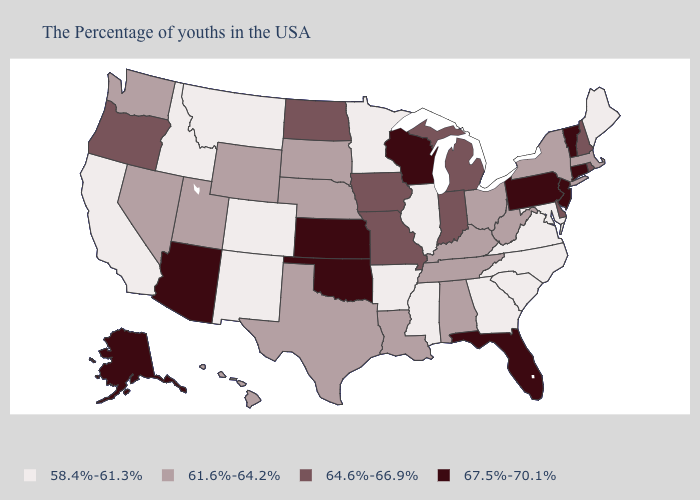Which states have the lowest value in the South?
Write a very short answer. Maryland, Virginia, North Carolina, South Carolina, Georgia, Mississippi, Arkansas. What is the highest value in the West ?
Be succinct. 67.5%-70.1%. Name the states that have a value in the range 61.6%-64.2%?
Give a very brief answer. Massachusetts, New York, West Virginia, Ohio, Kentucky, Alabama, Tennessee, Louisiana, Nebraska, Texas, South Dakota, Wyoming, Utah, Nevada, Washington, Hawaii. Does the map have missing data?
Give a very brief answer. No. How many symbols are there in the legend?
Keep it brief. 4. Which states have the lowest value in the Northeast?
Answer briefly. Maine. Which states have the lowest value in the USA?
Write a very short answer. Maine, Maryland, Virginia, North Carolina, South Carolina, Georgia, Illinois, Mississippi, Arkansas, Minnesota, Colorado, New Mexico, Montana, Idaho, California. What is the highest value in states that border Tennessee?
Be succinct. 64.6%-66.9%. Does the first symbol in the legend represent the smallest category?
Concise answer only. Yes. Name the states that have a value in the range 64.6%-66.9%?
Write a very short answer. Rhode Island, New Hampshire, Delaware, Michigan, Indiana, Missouri, Iowa, North Dakota, Oregon. Does Oklahoma have the highest value in the South?
Short answer required. Yes. Among the states that border New Mexico , does Oklahoma have the highest value?
Write a very short answer. Yes. How many symbols are there in the legend?
Give a very brief answer. 4. What is the value of Kansas?
Concise answer only. 67.5%-70.1%. What is the value of West Virginia?
Give a very brief answer. 61.6%-64.2%. 